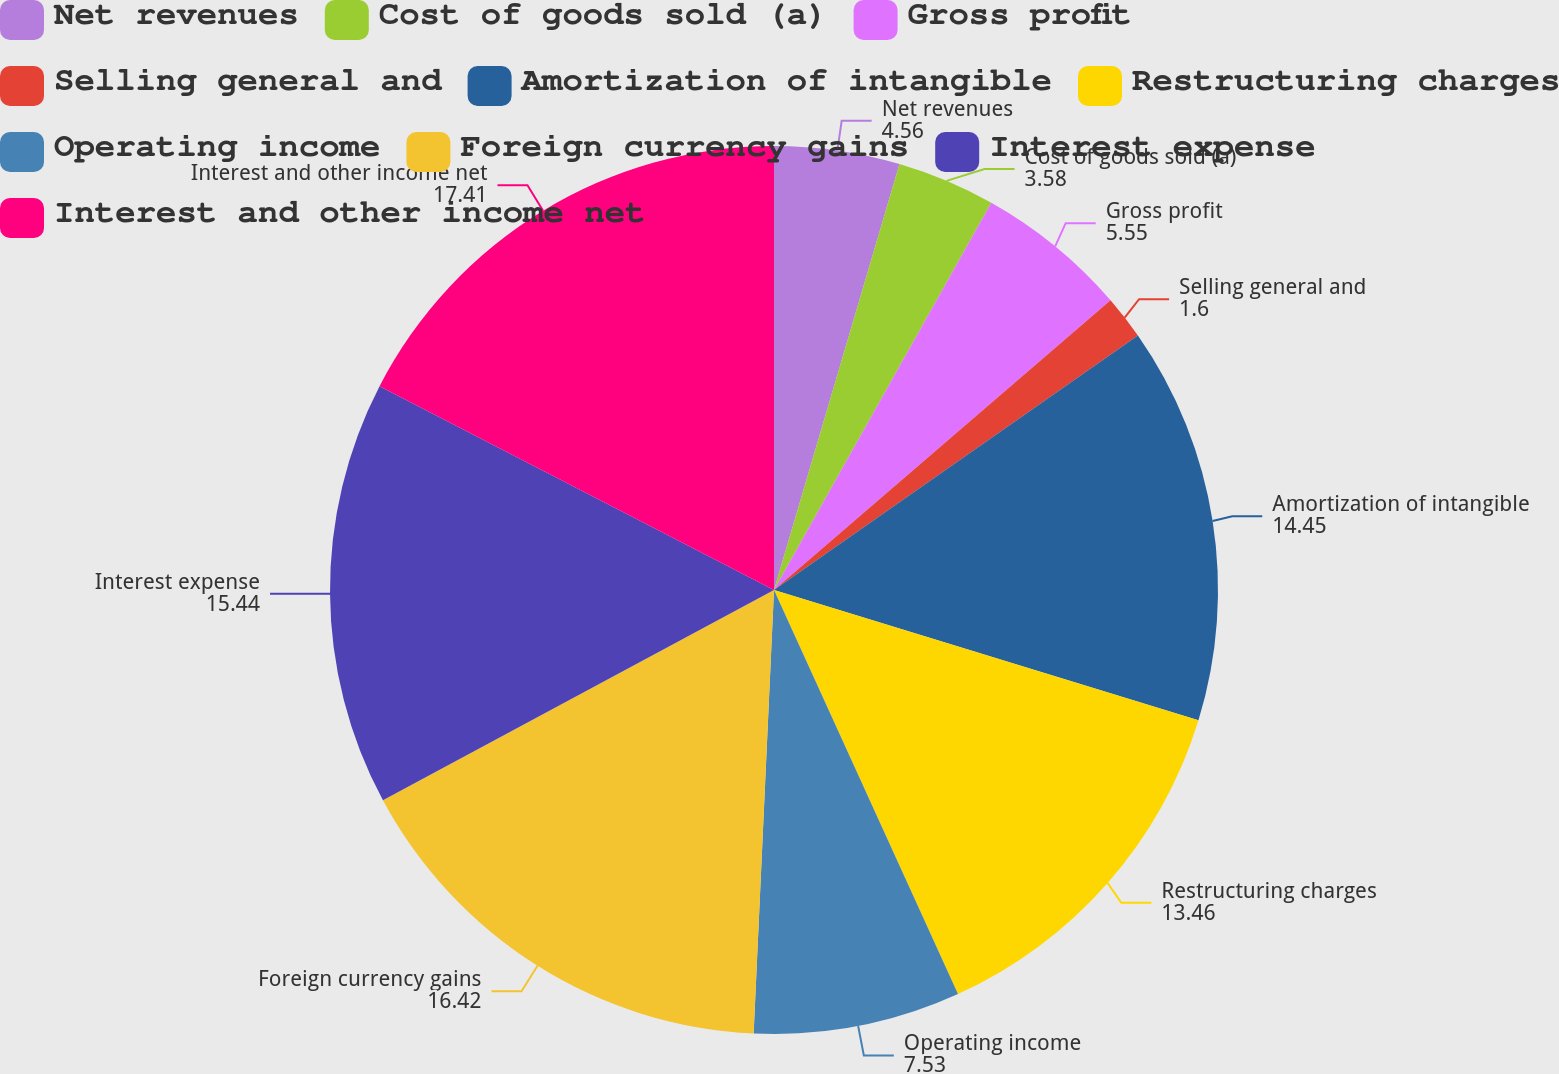Convert chart. <chart><loc_0><loc_0><loc_500><loc_500><pie_chart><fcel>Net revenues<fcel>Cost of goods sold (a)<fcel>Gross profit<fcel>Selling general and<fcel>Amortization of intangible<fcel>Restructuring charges<fcel>Operating income<fcel>Foreign currency gains<fcel>Interest expense<fcel>Interest and other income net<nl><fcel>4.56%<fcel>3.58%<fcel>5.55%<fcel>1.6%<fcel>14.45%<fcel>13.46%<fcel>7.53%<fcel>16.42%<fcel>15.44%<fcel>17.41%<nl></chart> 